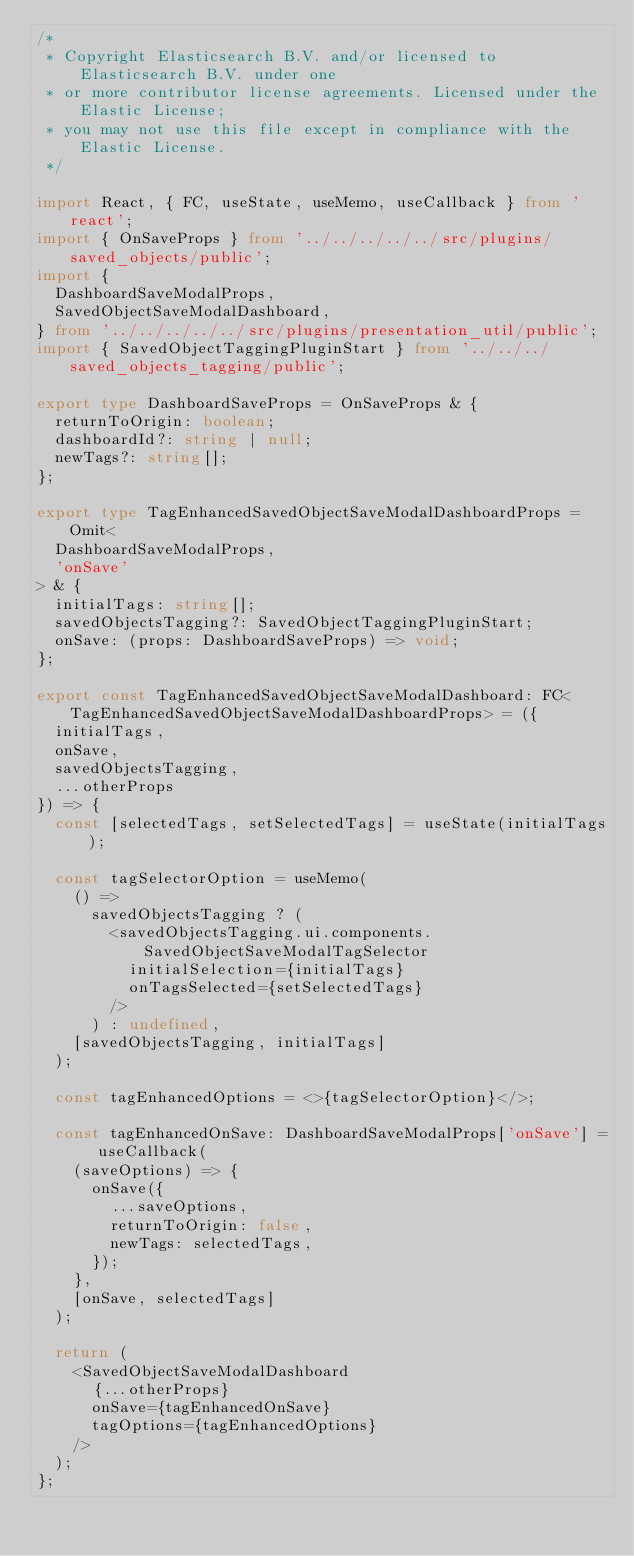<code> <loc_0><loc_0><loc_500><loc_500><_TypeScript_>/*
 * Copyright Elasticsearch B.V. and/or licensed to Elasticsearch B.V. under one
 * or more contributor license agreements. Licensed under the Elastic License;
 * you may not use this file except in compliance with the Elastic License.
 */

import React, { FC, useState, useMemo, useCallback } from 'react';
import { OnSaveProps } from '../../../../../src/plugins/saved_objects/public';
import {
  DashboardSaveModalProps,
  SavedObjectSaveModalDashboard,
} from '../../../../../src/plugins/presentation_util/public';
import { SavedObjectTaggingPluginStart } from '../../../saved_objects_tagging/public';

export type DashboardSaveProps = OnSaveProps & {
  returnToOrigin: boolean;
  dashboardId?: string | null;
  newTags?: string[];
};

export type TagEnhancedSavedObjectSaveModalDashboardProps = Omit<
  DashboardSaveModalProps,
  'onSave'
> & {
  initialTags: string[];
  savedObjectsTagging?: SavedObjectTaggingPluginStart;
  onSave: (props: DashboardSaveProps) => void;
};

export const TagEnhancedSavedObjectSaveModalDashboard: FC<TagEnhancedSavedObjectSaveModalDashboardProps> = ({
  initialTags,
  onSave,
  savedObjectsTagging,
  ...otherProps
}) => {
  const [selectedTags, setSelectedTags] = useState(initialTags);

  const tagSelectorOption = useMemo(
    () =>
      savedObjectsTagging ? (
        <savedObjectsTagging.ui.components.SavedObjectSaveModalTagSelector
          initialSelection={initialTags}
          onTagsSelected={setSelectedTags}
        />
      ) : undefined,
    [savedObjectsTagging, initialTags]
  );

  const tagEnhancedOptions = <>{tagSelectorOption}</>;

  const tagEnhancedOnSave: DashboardSaveModalProps['onSave'] = useCallback(
    (saveOptions) => {
      onSave({
        ...saveOptions,
        returnToOrigin: false,
        newTags: selectedTags,
      });
    },
    [onSave, selectedTags]
  );

  return (
    <SavedObjectSaveModalDashboard
      {...otherProps}
      onSave={tagEnhancedOnSave}
      tagOptions={tagEnhancedOptions}
    />
  );
};
</code> 